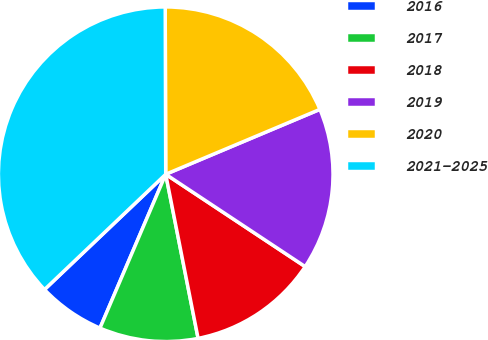Convert chart. <chart><loc_0><loc_0><loc_500><loc_500><pie_chart><fcel>2016<fcel>2017<fcel>2018<fcel>2019<fcel>2020<fcel>2021-2025<nl><fcel>6.47%<fcel>9.53%<fcel>12.59%<fcel>15.65%<fcel>18.71%<fcel>37.06%<nl></chart> 